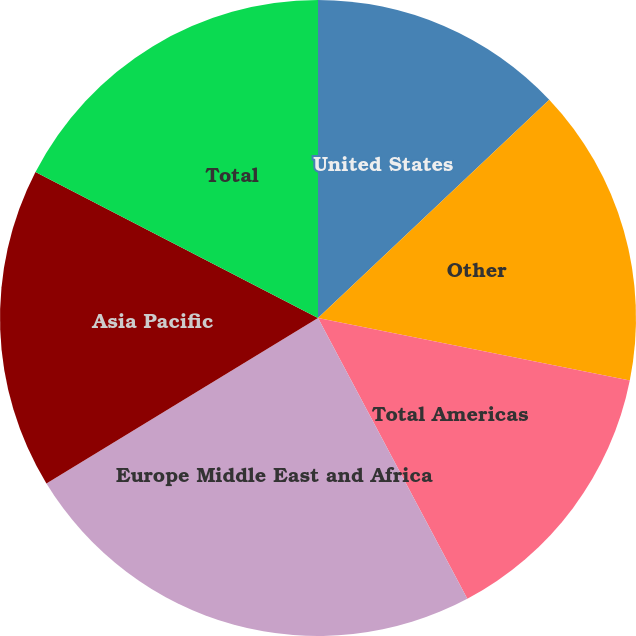<chart> <loc_0><loc_0><loc_500><loc_500><pie_chart><fcel>United States<fcel>Other<fcel>Total Americas<fcel>Europe Middle East and Africa<fcel>Asia Pacific<fcel>Total<nl><fcel>12.96%<fcel>15.19%<fcel>14.07%<fcel>24.07%<fcel>16.3%<fcel>17.41%<nl></chart> 